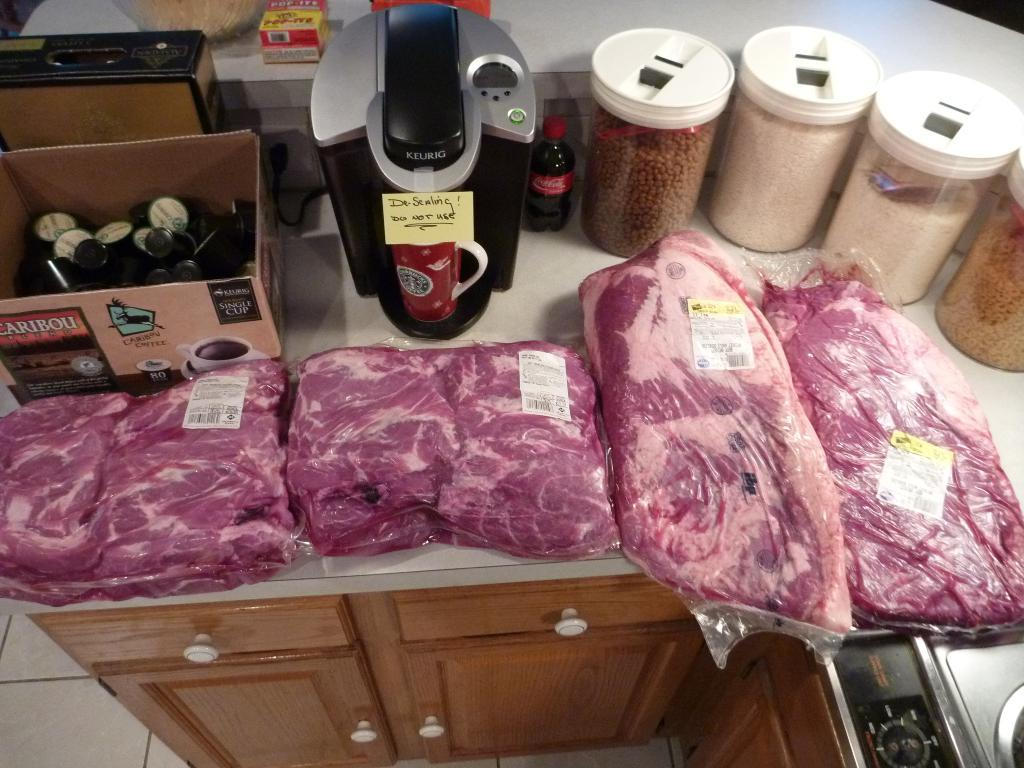<image>
Offer a succinct explanation of the picture presented. Large packs of meat sit on a counter next to a Caribou box 